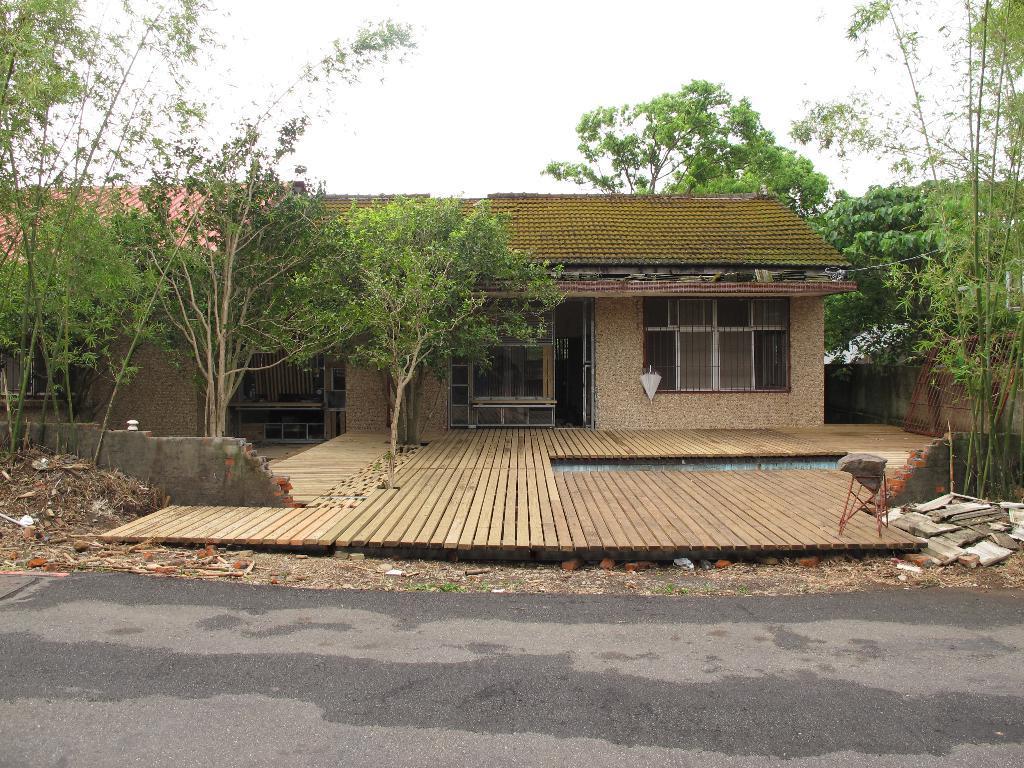Please provide a concise description of this image. In this image we can see a house, trees, grill, umbrella and sky.   